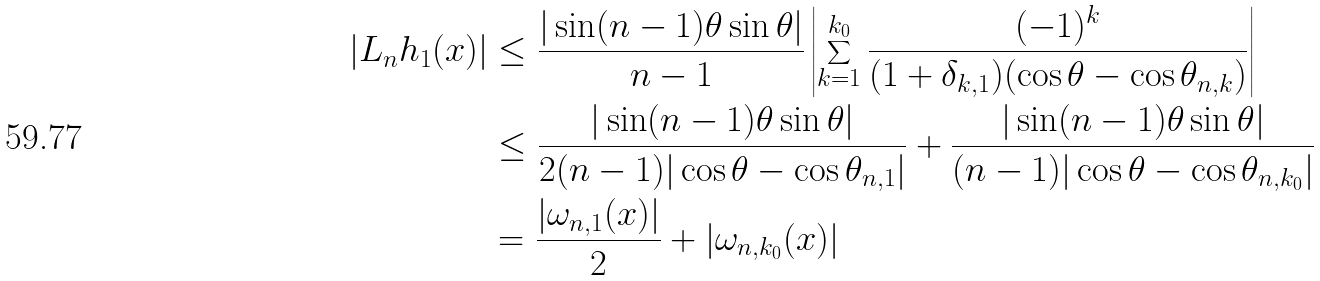<formula> <loc_0><loc_0><loc_500><loc_500>| L _ { n } h _ { 1 } ( x ) | & \leq \frac { | \sin ( n - 1 ) \theta \sin \theta | } { n - 1 } \left | \sum ^ { k _ { 0 } } _ { k = 1 } \frac { ( - 1 ) ^ { k } } { ( 1 + \delta _ { k , 1 } ) ( \cos \theta - \cos \theta _ { n , k } ) } \right | \\ & \leq \frac { | \sin ( n - 1 ) \theta \sin \theta | } { 2 ( n - 1 ) | \cos \theta - \cos \theta _ { n , 1 } | } + \frac { | \sin ( n - 1 ) \theta \sin \theta | } { ( n - 1 ) | \cos \theta - \cos \theta _ { n , k _ { 0 } } | } \\ & = \frac { | \omega _ { n , 1 } ( x ) | } { 2 } + | \omega _ { n , k _ { 0 } } ( x ) |</formula> 